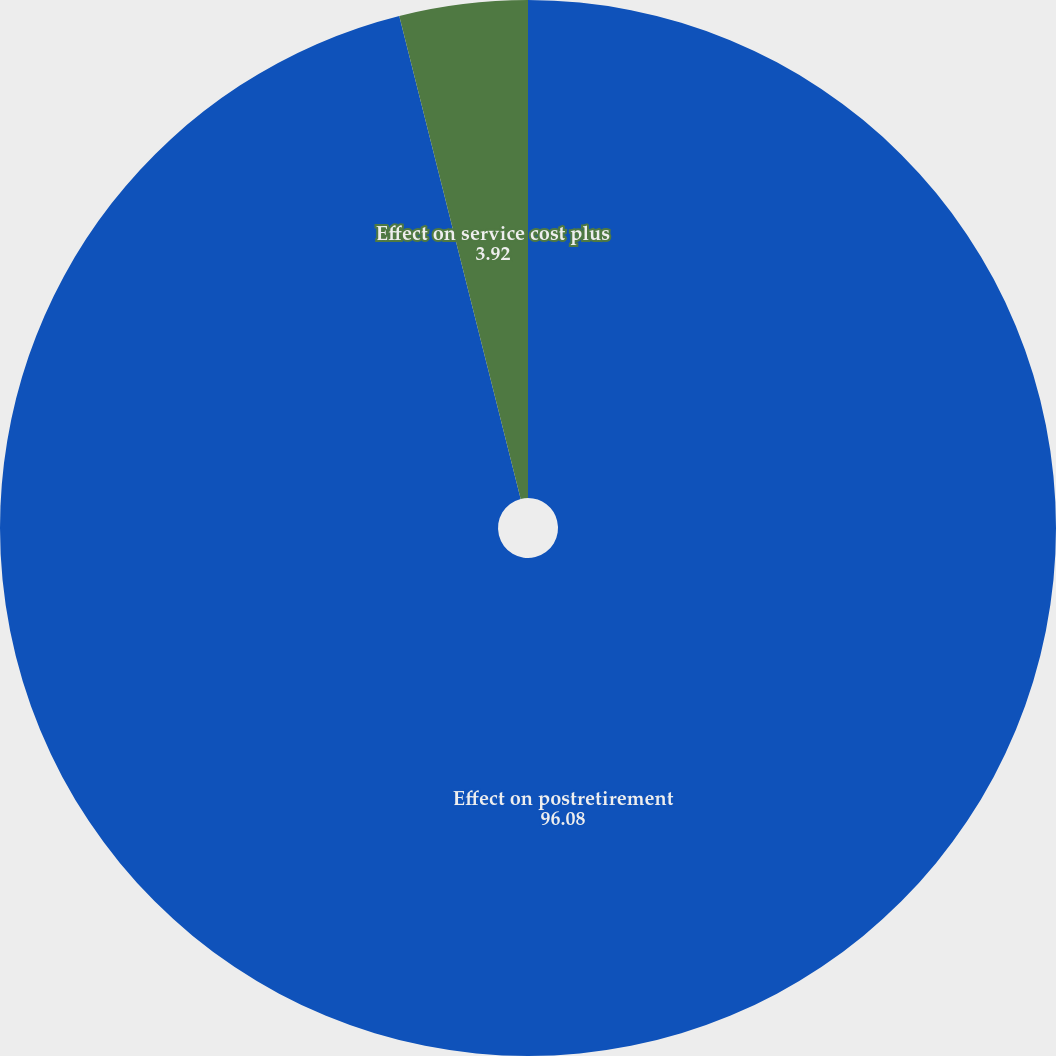Convert chart. <chart><loc_0><loc_0><loc_500><loc_500><pie_chart><fcel>Effect on postretirement<fcel>Effect on service cost plus<nl><fcel>96.08%<fcel>3.92%<nl></chart> 